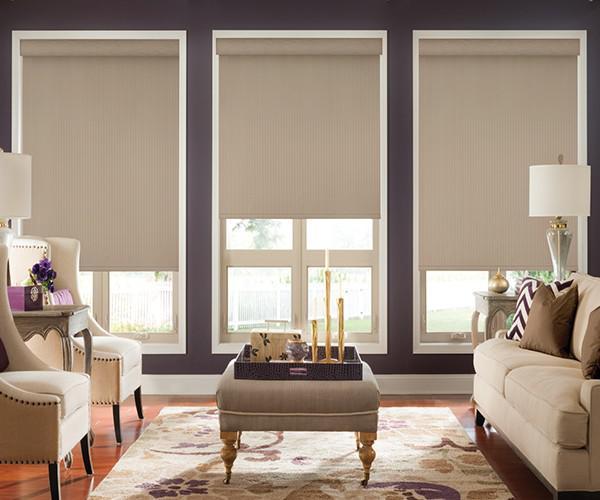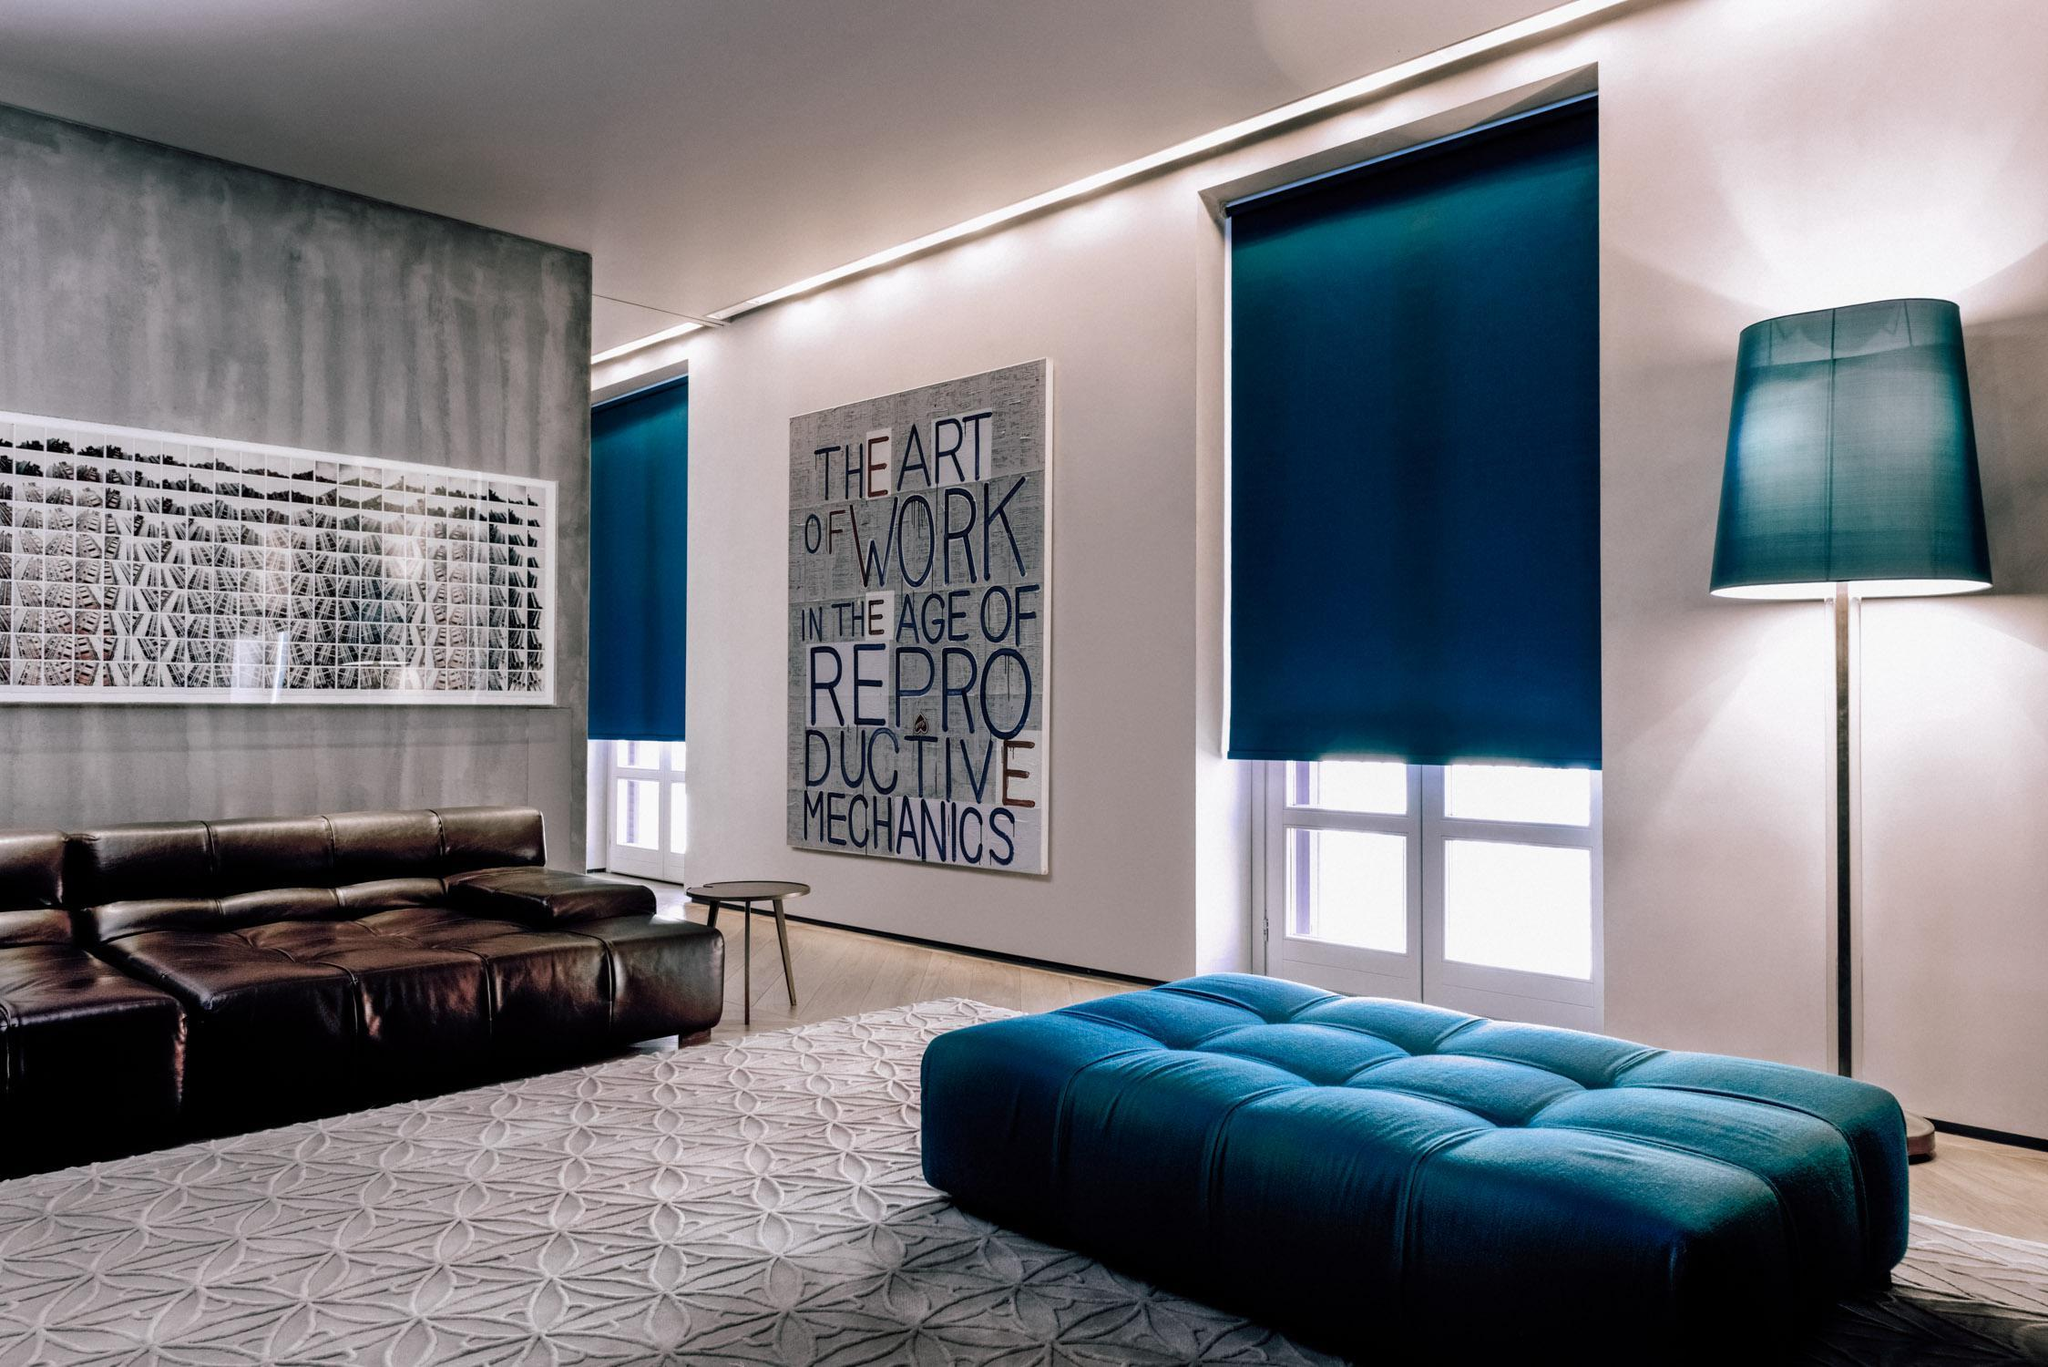The first image is the image on the left, the second image is the image on the right. For the images displayed, is the sentence "In at least one image there are three blinds  behind a sofa chair." factually correct? Answer yes or no. Yes. The first image is the image on the left, the second image is the image on the right. For the images displayed, is the sentence "All of the blinds in each image are open at equal lengths to the others in the same image." factually correct? Answer yes or no. No. 